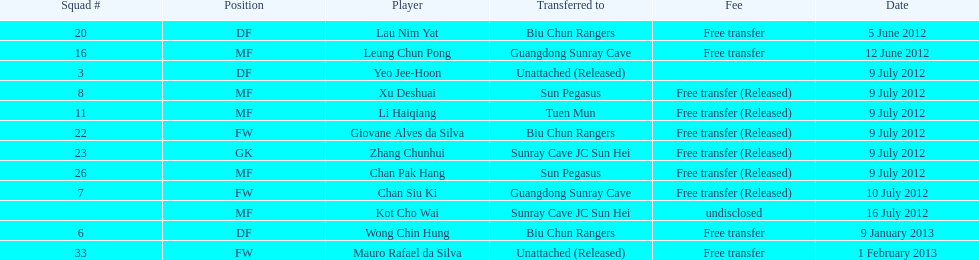Would you be able to parse every entry in this table? {'header': ['Squad #', 'Position', 'Player', 'Transferred to', 'Fee', 'Date'], 'rows': [['20', 'DF', 'Lau Nim Yat', 'Biu Chun Rangers', 'Free transfer', '5 June 2012'], ['16', 'MF', 'Leung Chun Pong', 'Guangdong Sunray Cave', 'Free transfer', '12 June 2012'], ['3', 'DF', 'Yeo Jee-Hoon', 'Unattached (Released)', '', '9 July 2012'], ['8', 'MF', 'Xu Deshuai', 'Sun Pegasus', 'Free transfer (Released)', '9 July 2012'], ['11', 'MF', 'Li Haiqiang', 'Tuen Mun', 'Free transfer (Released)', '9 July 2012'], ['22', 'FW', 'Giovane Alves da Silva', 'Biu Chun Rangers', 'Free transfer (Released)', '9 July 2012'], ['23', 'GK', 'Zhang Chunhui', 'Sunray Cave JC Sun Hei', 'Free transfer (Released)', '9 July 2012'], ['26', 'MF', 'Chan Pak Hang', 'Sun Pegasus', 'Free transfer (Released)', '9 July 2012'], ['7', 'FW', 'Chan Siu Ki', 'Guangdong Sunray Cave', 'Free transfer (Released)', '10 July 2012'], ['', 'MF', 'Kot Cho Wai', 'Sunray Cave JC Sun Hei', 'undisclosed', '16 July 2012'], ['6', 'DF', 'Wong Chin Hung', 'Biu Chun Rangers', 'Free transfer', '9 January 2013'], ['33', 'FW', 'Mauro Rafael da Silva', 'Unattached (Released)', 'Free transfer', '1 February 2013']]} Which position is adjacent to squad #3? DF. 